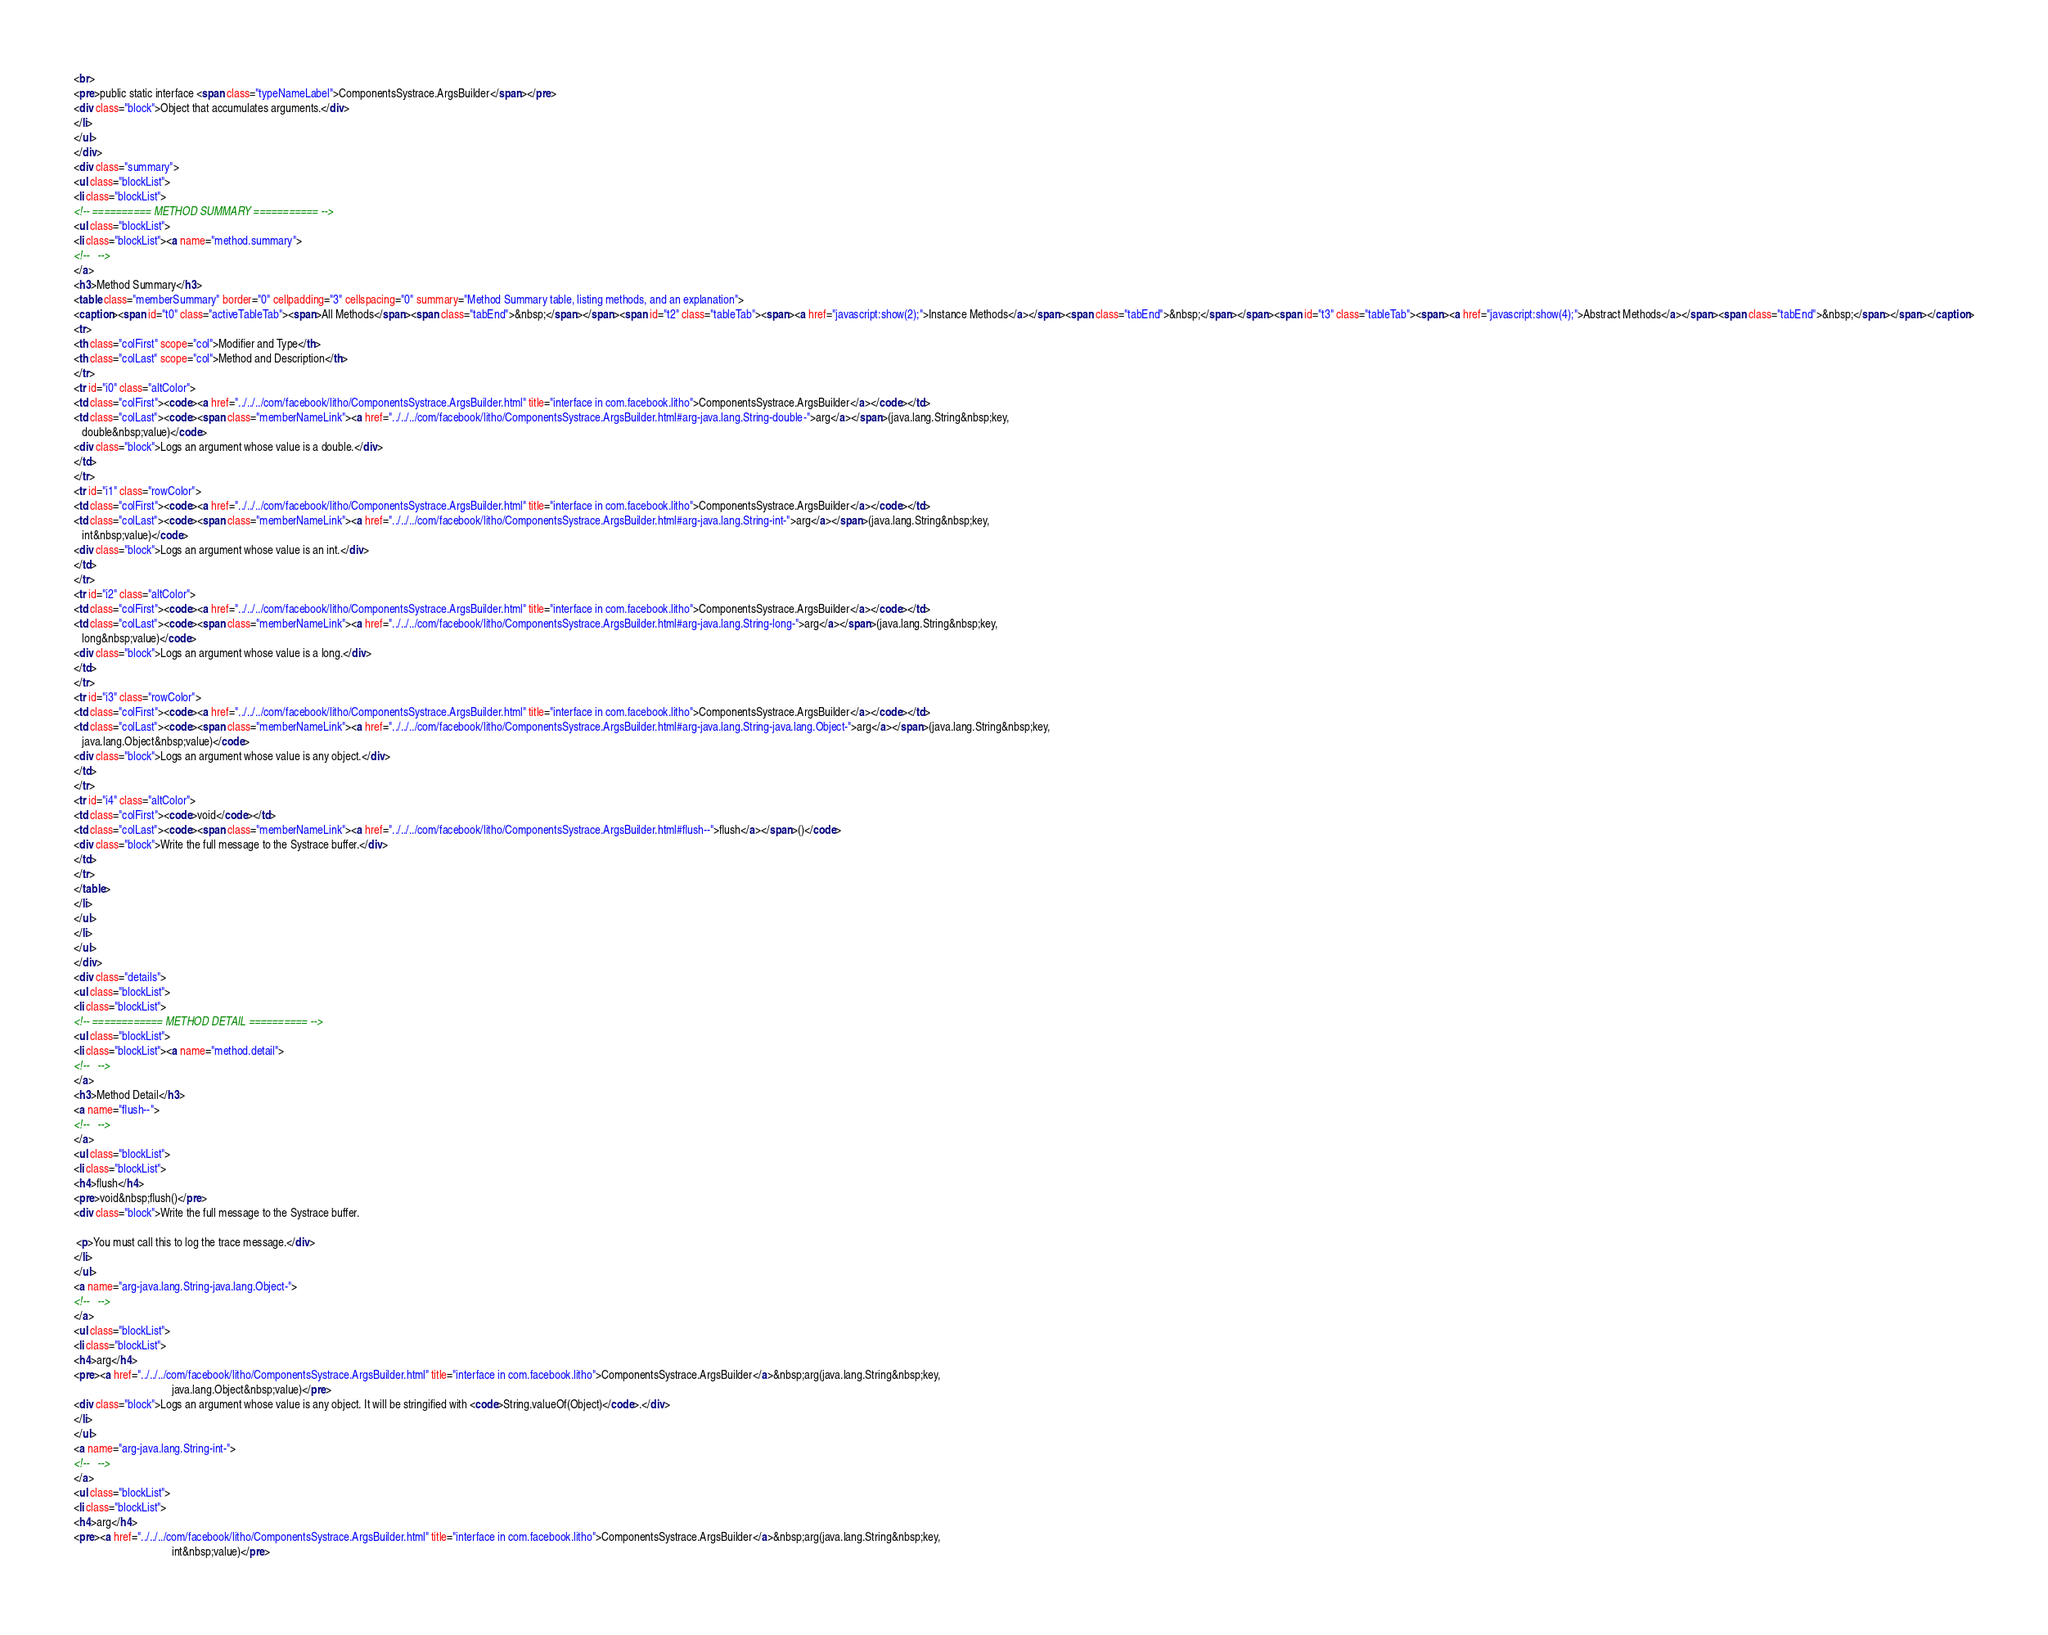<code> <loc_0><loc_0><loc_500><loc_500><_HTML_><br>
<pre>public static interface <span class="typeNameLabel">ComponentsSystrace.ArgsBuilder</span></pre>
<div class="block">Object that accumulates arguments.</div>
</li>
</ul>
</div>
<div class="summary">
<ul class="blockList">
<li class="blockList">
<!-- ========== METHOD SUMMARY =========== -->
<ul class="blockList">
<li class="blockList"><a name="method.summary">
<!--   -->
</a>
<h3>Method Summary</h3>
<table class="memberSummary" border="0" cellpadding="3" cellspacing="0" summary="Method Summary table, listing methods, and an explanation">
<caption><span id="t0" class="activeTableTab"><span>All Methods</span><span class="tabEnd">&nbsp;</span></span><span id="t2" class="tableTab"><span><a href="javascript:show(2);">Instance Methods</a></span><span class="tabEnd">&nbsp;</span></span><span id="t3" class="tableTab"><span><a href="javascript:show(4);">Abstract Methods</a></span><span class="tabEnd">&nbsp;</span></span></caption>
<tr>
<th class="colFirst" scope="col">Modifier and Type</th>
<th class="colLast" scope="col">Method and Description</th>
</tr>
<tr id="i0" class="altColor">
<td class="colFirst"><code><a href="../../../com/facebook/litho/ComponentsSystrace.ArgsBuilder.html" title="interface in com.facebook.litho">ComponentsSystrace.ArgsBuilder</a></code></td>
<td class="colLast"><code><span class="memberNameLink"><a href="../../../com/facebook/litho/ComponentsSystrace.ArgsBuilder.html#arg-java.lang.String-double-">arg</a></span>(java.lang.String&nbsp;key,
   double&nbsp;value)</code>
<div class="block">Logs an argument whose value is a double.</div>
</td>
</tr>
<tr id="i1" class="rowColor">
<td class="colFirst"><code><a href="../../../com/facebook/litho/ComponentsSystrace.ArgsBuilder.html" title="interface in com.facebook.litho">ComponentsSystrace.ArgsBuilder</a></code></td>
<td class="colLast"><code><span class="memberNameLink"><a href="../../../com/facebook/litho/ComponentsSystrace.ArgsBuilder.html#arg-java.lang.String-int-">arg</a></span>(java.lang.String&nbsp;key,
   int&nbsp;value)</code>
<div class="block">Logs an argument whose value is an int.</div>
</td>
</tr>
<tr id="i2" class="altColor">
<td class="colFirst"><code><a href="../../../com/facebook/litho/ComponentsSystrace.ArgsBuilder.html" title="interface in com.facebook.litho">ComponentsSystrace.ArgsBuilder</a></code></td>
<td class="colLast"><code><span class="memberNameLink"><a href="../../../com/facebook/litho/ComponentsSystrace.ArgsBuilder.html#arg-java.lang.String-long-">arg</a></span>(java.lang.String&nbsp;key,
   long&nbsp;value)</code>
<div class="block">Logs an argument whose value is a long.</div>
</td>
</tr>
<tr id="i3" class="rowColor">
<td class="colFirst"><code><a href="../../../com/facebook/litho/ComponentsSystrace.ArgsBuilder.html" title="interface in com.facebook.litho">ComponentsSystrace.ArgsBuilder</a></code></td>
<td class="colLast"><code><span class="memberNameLink"><a href="../../../com/facebook/litho/ComponentsSystrace.ArgsBuilder.html#arg-java.lang.String-java.lang.Object-">arg</a></span>(java.lang.String&nbsp;key,
   java.lang.Object&nbsp;value)</code>
<div class="block">Logs an argument whose value is any object.</div>
</td>
</tr>
<tr id="i4" class="altColor">
<td class="colFirst"><code>void</code></td>
<td class="colLast"><code><span class="memberNameLink"><a href="../../../com/facebook/litho/ComponentsSystrace.ArgsBuilder.html#flush--">flush</a></span>()</code>
<div class="block">Write the full message to the Systrace buffer.</div>
</td>
</tr>
</table>
</li>
</ul>
</li>
</ul>
</div>
<div class="details">
<ul class="blockList">
<li class="blockList">
<!-- ============ METHOD DETAIL ========== -->
<ul class="blockList">
<li class="blockList"><a name="method.detail">
<!--   -->
</a>
<h3>Method Detail</h3>
<a name="flush--">
<!--   -->
</a>
<ul class="blockList">
<li class="blockList">
<h4>flush</h4>
<pre>void&nbsp;flush()</pre>
<div class="block">Write the full message to the Systrace buffer.

 <p>You must call this to log the trace message.</div>
</li>
</ul>
<a name="arg-java.lang.String-java.lang.Object-">
<!--   -->
</a>
<ul class="blockList">
<li class="blockList">
<h4>arg</h4>
<pre><a href="../../../com/facebook/litho/ComponentsSystrace.ArgsBuilder.html" title="interface in com.facebook.litho">ComponentsSystrace.ArgsBuilder</a>&nbsp;arg(java.lang.String&nbsp;key,
                                   java.lang.Object&nbsp;value)</pre>
<div class="block">Logs an argument whose value is any object. It will be stringified with <code>String.valueOf(Object)</code>.</div>
</li>
</ul>
<a name="arg-java.lang.String-int-">
<!--   -->
</a>
<ul class="blockList">
<li class="blockList">
<h4>arg</h4>
<pre><a href="../../../com/facebook/litho/ComponentsSystrace.ArgsBuilder.html" title="interface in com.facebook.litho">ComponentsSystrace.ArgsBuilder</a>&nbsp;arg(java.lang.String&nbsp;key,
                                   int&nbsp;value)</pre></code> 